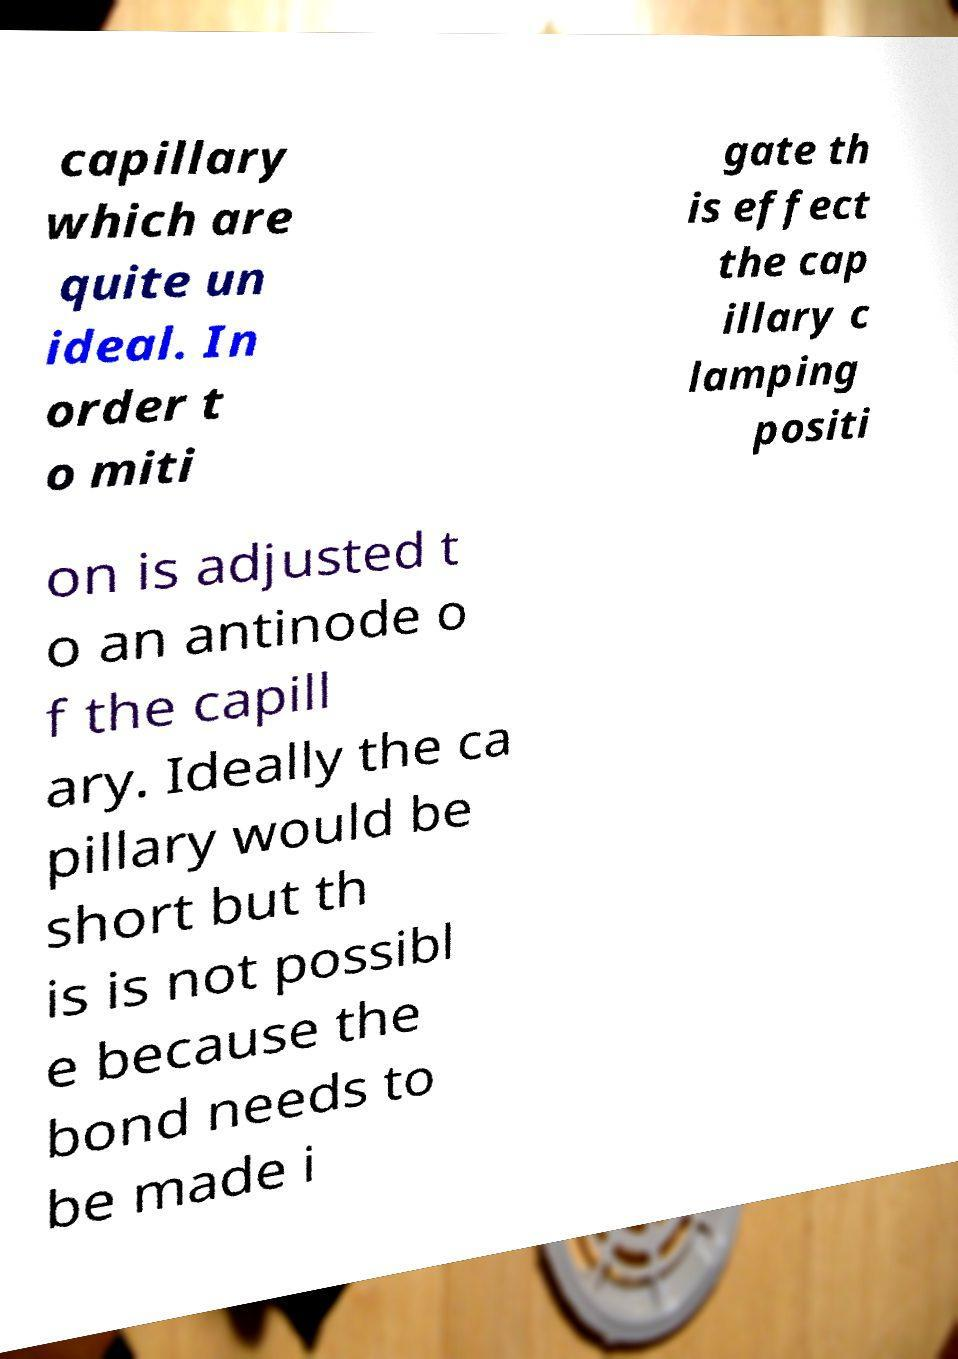I need the written content from this picture converted into text. Can you do that? capillary which are quite un ideal. In order t o miti gate th is effect the cap illary c lamping positi on is adjusted t o an antinode o f the capill ary. Ideally the ca pillary would be short but th is is not possibl e because the bond needs to be made i 